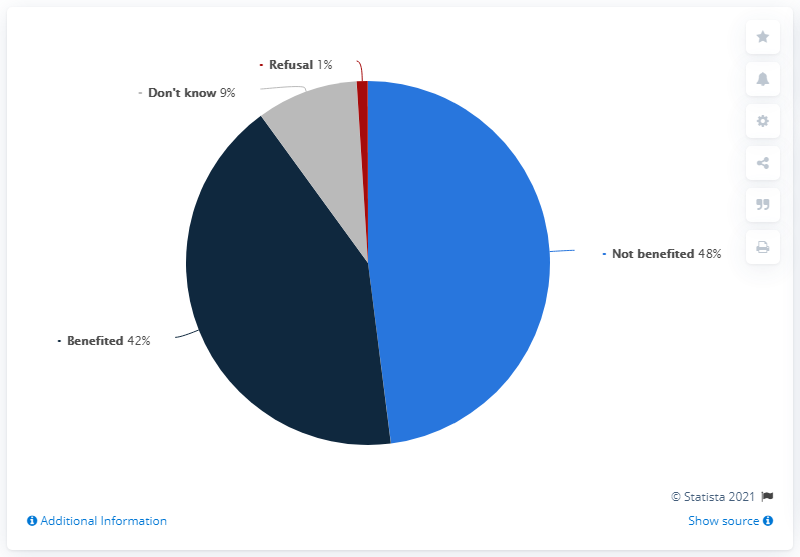Specify some key components in this picture. The most popular response is 'Not benefited,' indicating that many customers are not finding the feature useful. The sum of responses that are negative is 58. 